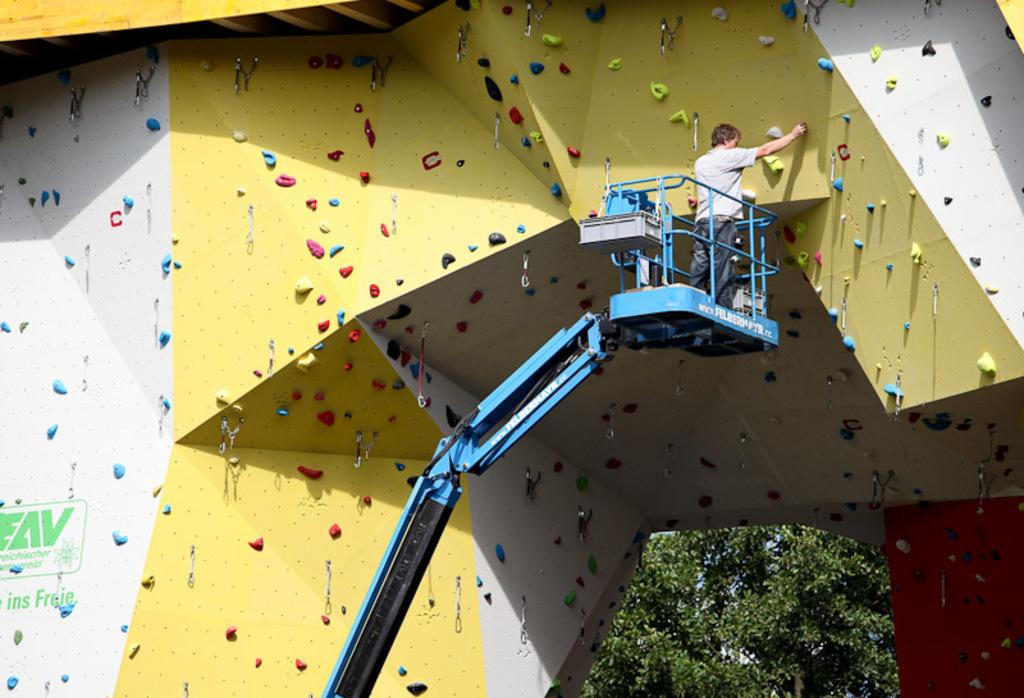What activity is being performed in the image? There is bouldering in the image. Can you describe the person in the image? There is a person in the image. What type of natural environment is visible in the image? There are trees in the image. Are there any cobwebs visible on the bouldering wall in the image? There is no mention of cobwebs in the provided facts, so we cannot determine if any are present in the image. What type of steel is used to construct the bouldering wall in the image? There is no information about the materials used to construct the bouldering wall in the image, so we cannot determine the type of steel used. 